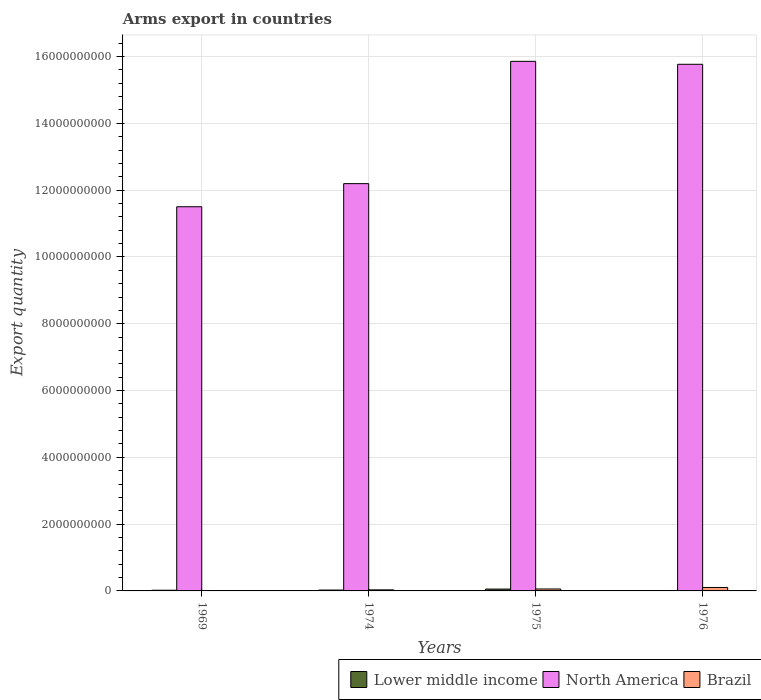How many different coloured bars are there?
Make the answer very short. 3. How many groups of bars are there?
Keep it short and to the point. 4. Are the number of bars on each tick of the X-axis equal?
Your answer should be very brief. Yes. How many bars are there on the 2nd tick from the left?
Keep it short and to the point. 3. What is the label of the 2nd group of bars from the left?
Ensure brevity in your answer.  1974. In how many cases, is the number of bars for a given year not equal to the number of legend labels?
Offer a very short reply. 0. What is the total arms export in Brazil in 1975?
Provide a short and direct response. 5.80e+07. Across all years, what is the maximum total arms export in North America?
Offer a very short reply. 1.59e+1. Across all years, what is the minimum total arms export in North America?
Your response must be concise. 1.15e+1. In which year was the total arms export in Lower middle income maximum?
Provide a short and direct response. 1975. In which year was the total arms export in North America minimum?
Your answer should be compact. 1969. What is the total total arms export in North America in the graph?
Provide a succinct answer. 5.53e+1. What is the difference between the total arms export in Lower middle income in 1974 and that in 1975?
Provide a succinct answer. -2.90e+07. What is the difference between the total arms export in Brazil in 1969 and the total arms export in North America in 1976?
Provide a succinct answer. -1.58e+1. What is the average total arms export in Brazil per year?
Make the answer very short. 4.90e+07. In the year 1969, what is the difference between the total arms export in North America and total arms export in Lower middle income?
Offer a terse response. 1.15e+1. What is the ratio of the total arms export in Brazil in 1969 to that in 1974?
Provide a succinct answer. 0.09. Is the difference between the total arms export in North America in 1969 and 1974 greater than the difference between the total arms export in Lower middle income in 1969 and 1974?
Provide a succinct answer. No. What is the difference between the highest and the second highest total arms export in Lower middle income?
Your answer should be compact. 2.90e+07. What is the difference between the highest and the lowest total arms export in North America?
Offer a very short reply. 4.35e+09. In how many years, is the total arms export in Brazil greater than the average total arms export in Brazil taken over all years?
Your answer should be very brief. 2. What does the 1st bar from the right in 1974 represents?
Provide a succinct answer. Brazil. How many bars are there?
Provide a short and direct response. 12. Does the graph contain grids?
Ensure brevity in your answer.  Yes. Where does the legend appear in the graph?
Ensure brevity in your answer.  Bottom right. How are the legend labels stacked?
Provide a succinct answer. Horizontal. What is the title of the graph?
Provide a short and direct response. Arms export in countries. What is the label or title of the Y-axis?
Ensure brevity in your answer.  Export quantity. What is the Export quantity in Lower middle income in 1969?
Your response must be concise. 2.10e+07. What is the Export quantity in North America in 1969?
Give a very brief answer. 1.15e+1. What is the Export quantity in Brazil in 1969?
Keep it short and to the point. 3.00e+06. What is the Export quantity in Lower middle income in 1974?
Offer a terse response. 2.60e+07. What is the Export quantity in North America in 1974?
Your answer should be compact. 1.22e+1. What is the Export quantity of Brazil in 1974?
Provide a succinct answer. 3.20e+07. What is the Export quantity in Lower middle income in 1975?
Give a very brief answer. 5.50e+07. What is the Export quantity of North America in 1975?
Provide a short and direct response. 1.59e+1. What is the Export quantity in Brazil in 1975?
Provide a succinct answer. 5.80e+07. What is the Export quantity of Lower middle income in 1976?
Ensure brevity in your answer.  5.00e+06. What is the Export quantity in North America in 1976?
Provide a short and direct response. 1.58e+1. What is the Export quantity in Brazil in 1976?
Offer a terse response. 1.03e+08. Across all years, what is the maximum Export quantity of Lower middle income?
Your answer should be compact. 5.50e+07. Across all years, what is the maximum Export quantity of North America?
Give a very brief answer. 1.59e+1. Across all years, what is the maximum Export quantity in Brazil?
Your answer should be compact. 1.03e+08. Across all years, what is the minimum Export quantity of Lower middle income?
Offer a terse response. 5.00e+06. Across all years, what is the minimum Export quantity of North America?
Keep it short and to the point. 1.15e+1. What is the total Export quantity in Lower middle income in the graph?
Provide a succinct answer. 1.07e+08. What is the total Export quantity of North America in the graph?
Your answer should be very brief. 5.53e+1. What is the total Export quantity of Brazil in the graph?
Provide a short and direct response. 1.96e+08. What is the difference between the Export quantity of Lower middle income in 1969 and that in 1974?
Keep it short and to the point. -5.00e+06. What is the difference between the Export quantity of North America in 1969 and that in 1974?
Your answer should be very brief. -6.92e+08. What is the difference between the Export quantity in Brazil in 1969 and that in 1974?
Keep it short and to the point. -2.90e+07. What is the difference between the Export quantity of Lower middle income in 1969 and that in 1975?
Provide a short and direct response. -3.40e+07. What is the difference between the Export quantity in North America in 1969 and that in 1975?
Your response must be concise. -4.35e+09. What is the difference between the Export quantity of Brazil in 1969 and that in 1975?
Your answer should be very brief. -5.50e+07. What is the difference between the Export quantity of Lower middle income in 1969 and that in 1976?
Offer a very short reply. 1.60e+07. What is the difference between the Export quantity of North America in 1969 and that in 1976?
Your answer should be very brief. -4.26e+09. What is the difference between the Export quantity of Brazil in 1969 and that in 1976?
Make the answer very short. -1.00e+08. What is the difference between the Export quantity of Lower middle income in 1974 and that in 1975?
Ensure brevity in your answer.  -2.90e+07. What is the difference between the Export quantity of North America in 1974 and that in 1975?
Your response must be concise. -3.66e+09. What is the difference between the Export quantity in Brazil in 1974 and that in 1975?
Provide a succinct answer. -2.60e+07. What is the difference between the Export quantity of Lower middle income in 1974 and that in 1976?
Your response must be concise. 2.10e+07. What is the difference between the Export quantity of North America in 1974 and that in 1976?
Give a very brief answer. -3.57e+09. What is the difference between the Export quantity of Brazil in 1974 and that in 1976?
Give a very brief answer. -7.10e+07. What is the difference between the Export quantity in North America in 1975 and that in 1976?
Keep it short and to the point. 8.80e+07. What is the difference between the Export quantity of Brazil in 1975 and that in 1976?
Give a very brief answer. -4.50e+07. What is the difference between the Export quantity of Lower middle income in 1969 and the Export quantity of North America in 1974?
Provide a short and direct response. -1.22e+1. What is the difference between the Export quantity in Lower middle income in 1969 and the Export quantity in Brazil in 1974?
Give a very brief answer. -1.10e+07. What is the difference between the Export quantity of North America in 1969 and the Export quantity of Brazil in 1974?
Give a very brief answer. 1.15e+1. What is the difference between the Export quantity in Lower middle income in 1969 and the Export quantity in North America in 1975?
Provide a short and direct response. -1.58e+1. What is the difference between the Export quantity in Lower middle income in 1969 and the Export quantity in Brazil in 1975?
Make the answer very short. -3.70e+07. What is the difference between the Export quantity in North America in 1969 and the Export quantity in Brazil in 1975?
Your answer should be very brief. 1.14e+1. What is the difference between the Export quantity of Lower middle income in 1969 and the Export quantity of North America in 1976?
Provide a short and direct response. -1.57e+1. What is the difference between the Export quantity in Lower middle income in 1969 and the Export quantity in Brazil in 1976?
Give a very brief answer. -8.20e+07. What is the difference between the Export quantity in North America in 1969 and the Export quantity in Brazil in 1976?
Your answer should be very brief. 1.14e+1. What is the difference between the Export quantity in Lower middle income in 1974 and the Export quantity in North America in 1975?
Your response must be concise. -1.58e+1. What is the difference between the Export quantity of Lower middle income in 1974 and the Export quantity of Brazil in 1975?
Keep it short and to the point. -3.20e+07. What is the difference between the Export quantity of North America in 1974 and the Export quantity of Brazil in 1975?
Ensure brevity in your answer.  1.21e+1. What is the difference between the Export quantity of Lower middle income in 1974 and the Export quantity of North America in 1976?
Keep it short and to the point. -1.57e+1. What is the difference between the Export quantity of Lower middle income in 1974 and the Export quantity of Brazil in 1976?
Your answer should be very brief. -7.70e+07. What is the difference between the Export quantity in North America in 1974 and the Export quantity in Brazil in 1976?
Provide a succinct answer. 1.21e+1. What is the difference between the Export quantity of Lower middle income in 1975 and the Export quantity of North America in 1976?
Provide a short and direct response. -1.57e+1. What is the difference between the Export quantity of Lower middle income in 1975 and the Export quantity of Brazil in 1976?
Offer a very short reply. -4.80e+07. What is the difference between the Export quantity in North America in 1975 and the Export quantity in Brazil in 1976?
Give a very brief answer. 1.58e+1. What is the average Export quantity of Lower middle income per year?
Keep it short and to the point. 2.68e+07. What is the average Export quantity of North America per year?
Ensure brevity in your answer.  1.38e+1. What is the average Export quantity in Brazil per year?
Keep it short and to the point. 4.90e+07. In the year 1969, what is the difference between the Export quantity of Lower middle income and Export quantity of North America?
Your answer should be very brief. -1.15e+1. In the year 1969, what is the difference between the Export quantity in Lower middle income and Export quantity in Brazil?
Keep it short and to the point. 1.80e+07. In the year 1969, what is the difference between the Export quantity in North America and Export quantity in Brazil?
Ensure brevity in your answer.  1.15e+1. In the year 1974, what is the difference between the Export quantity of Lower middle income and Export quantity of North America?
Your response must be concise. -1.22e+1. In the year 1974, what is the difference between the Export quantity of Lower middle income and Export quantity of Brazil?
Provide a short and direct response. -6.00e+06. In the year 1974, what is the difference between the Export quantity in North America and Export quantity in Brazil?
Provide a short and direct response. 1.22e+1. In the year 1975, what is the difference between the Export quantity in Lower middle income and Export quantity in North America?
Your answer should be compact. -1.58e+1. In the year 1975, what is the difference between the Export quantity of Lower middle income and Export quantity of Brazil?
Your answer should be compact. -3.00e+06. In the year 1975, what is the difference between the Export quantity of North America and Export quantity of Brazil?
Offer a terse response. 1.58e+1. In the year 1976, what is the difference between the Export quantity in Lower middle income and Export quantity in North America?
Ensure brevity in your answer.  -1.58e+1. In the year 1976, what is the difference between the Export quantity of Lower middle income and Export quantity of Brazil?
Your answer should be very brief. -9.80e+07. In the year 1976, what is the difference between the Export quantity in North America and Export quantity in Brazil?
Your answer should be very brief. 1.57e+1. What is the ratio of the Export quantity of Lower middle income in 1969 to that in 1974?
Keep it short and to the point. 0.81. What is the ratio of the Export quantity in North America in 1969 to that in 1974?
Offer a very short reply. 0.94. What is the ratio of the Export quantity in Brazil in 1969 to that in 1974?
Your answer should be very brief. 0.09. What is the ratio of the Export quantity of Lower middle income in 1969 to that in 1975?
Provide a short and direct response. 0.38. What is the ratio of the Export quantity in North America in 1969 to that in 1975?
Your answer should be compact. 0.73. What is the ratio of the Export quantity in Brazil in 1969 to that in 1975?
Offer a very short reply. 0.05. What is the ratio of the Export quantity of North America in 1969 to that in 1976?
Your answer should be very brief. 0.73. What is the ratio of the Export quantity in Brazil in 1969 to that in 1976?
Ensure brevity in your answer.  0.03. What is the ratio of the Export quantity in Lower middle income in 1974 to that in 1975?
Your response must be concise. 0.47. What is the ratio of the Export quantity in North America in 1974 to that in 1975?
Provide a short and direct response. 0.77. What is the ratio of the Export quantity in Brazil in 1974 to that in 1975?
Offer a very short reply. 0.55. What is the ratio of the Export quantity in North America in 1974 to that in 1976?
Keep it short and to the point. 0.77. What is the ratio of the Export quantity in Brazil in 1974 to that in 1976?
Offer a terse response. 0.31. What is the ratio of the Export quantity in Lower middle income in 1975 to that in 1976?
Keep it short and to the point. 11. What is the ratio of the Export quantity of North America in 1975 to that in 1976?
Provide a short and direct response. 1.01. What is the ratio of the Export quantity in Brazil in 1975 to that in 1976?
Your answer should be very brief. 0.56. What is the difference between the highest and the second highest Export quantity in Lower middle income?
Provide a short and direct response. 2.90e+07. What is the difference between the highest and the second highest Export quantity in North America?
Provide a succinct answer. 8.80e+07. What is the difference between the highest and the second highest Export quantity of Brazil?
Your answer should be compact. 4.50e+07. What is the difference between the highest and the lowest Export quantity of North America?
Provide a short and direct response. 4.35e+09. What is the difference between the highest and the lowest Export quantity of Brazil?
Your response must be concise. 1.00e+08. 